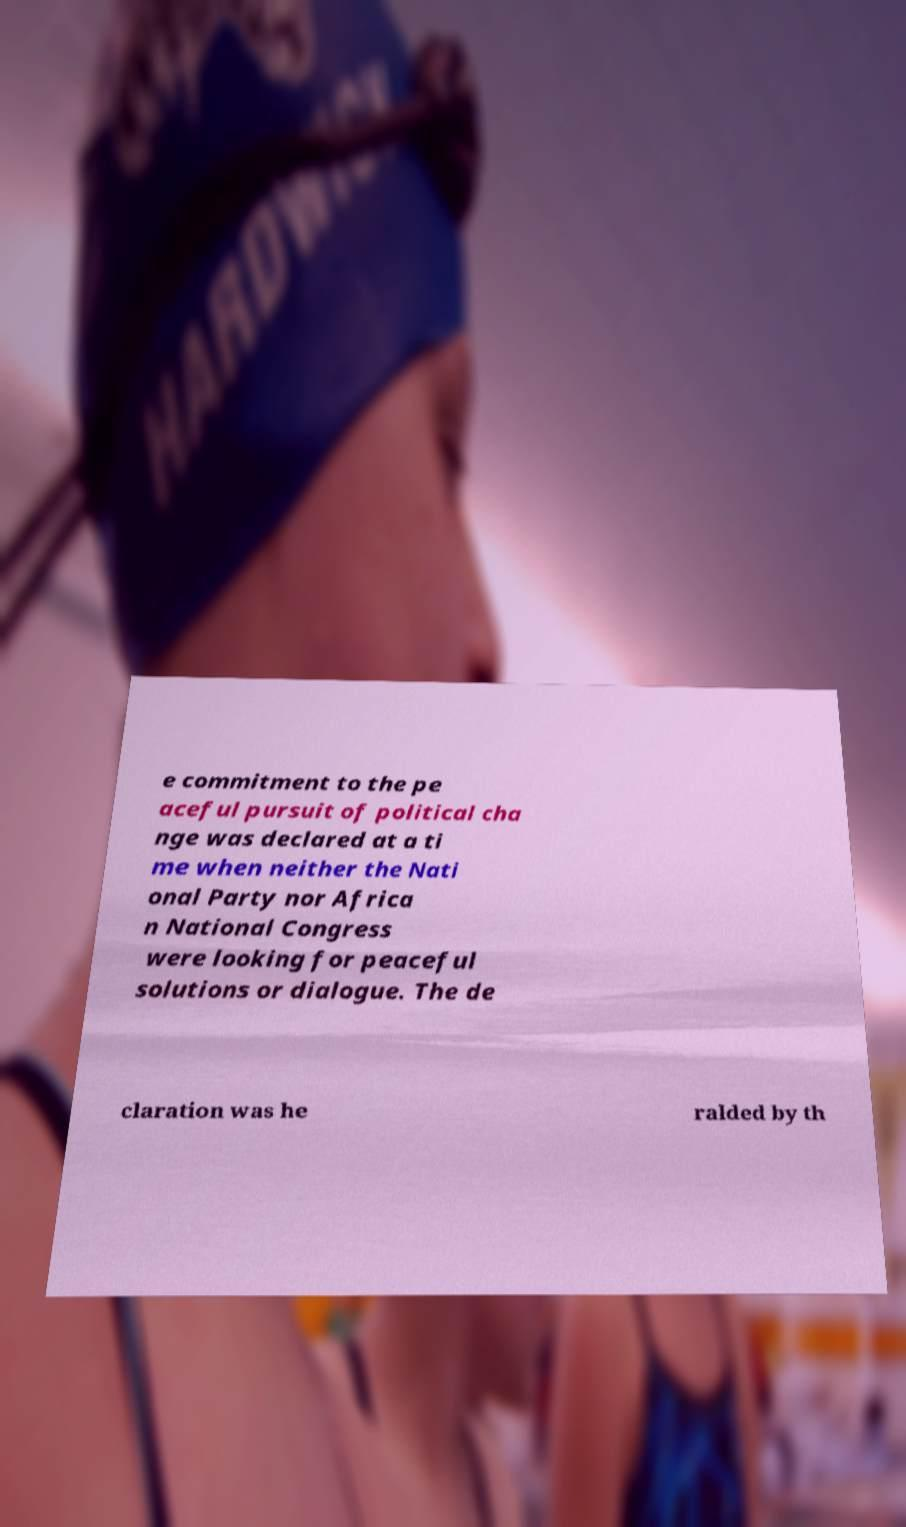Could you assist in decoding the text presented in this image and type it out clearly? e commitment to the pe aceful pursuit of political cha nge was declared at a ti me when neither the Nati onal Party nor Africa n National Congress were looking for peaceful solutions or dialogue. The de claration was he ralded by th 